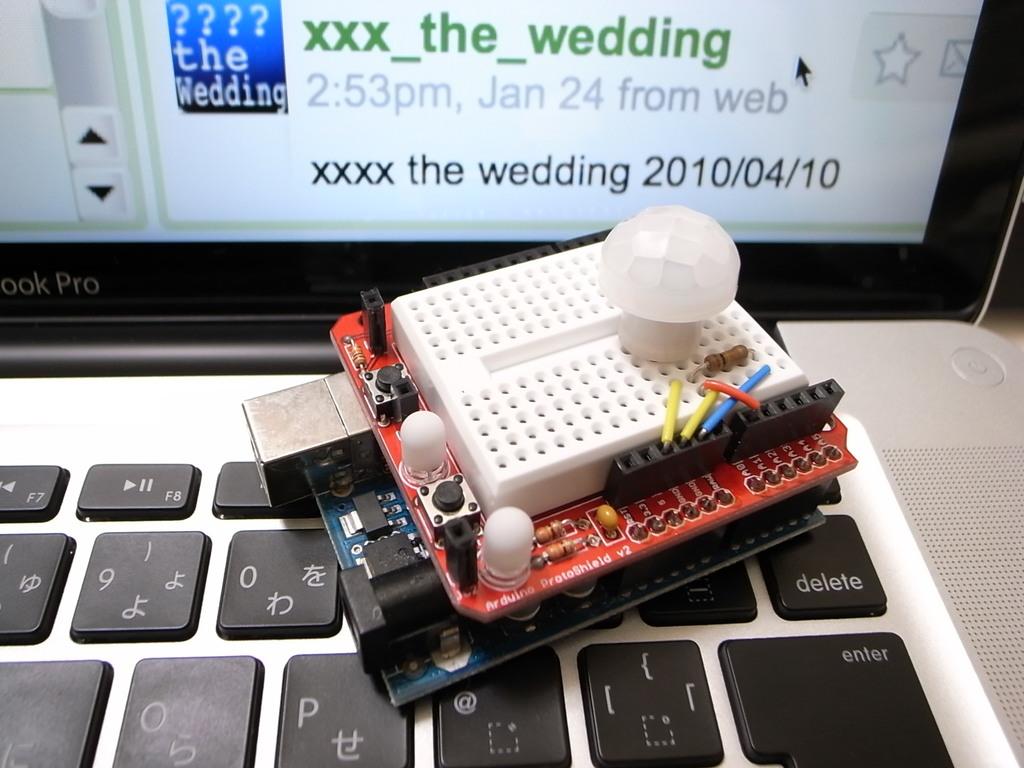What month is in this picture?
Provide a short and direct response. January. What is the time stated on the computer?
Your answer should be compact. 2:53pm. 